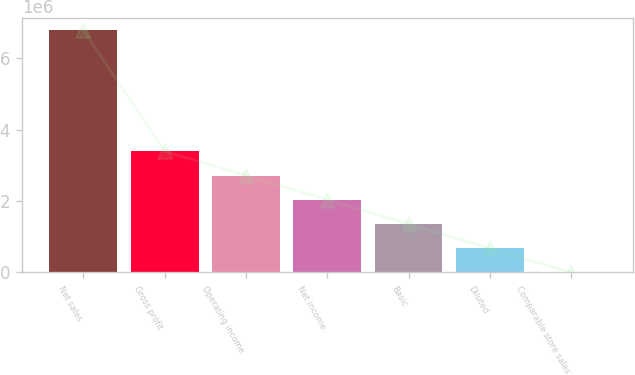<chart> <loc_0><loc_0><loc_500><loc_500><bar_chart><fcel>Net sales<fcel>Gross profit<fcel>Operating income<fcel>Net income<fcel>Basic<fcel>Diluted<fcel>Comparable store sales<nl><fcel>6.77958e+06<fcel>3.38979e+06<fcel>2.71183e+06<fcel>2.03387e+06<fcel>1.35592e+06<fcel>677959<fcel>1.6<nl></chart> 